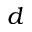Convert formula to latex. <formula><loc_0><loc_0><loc_500><loc_500>d</formula> 